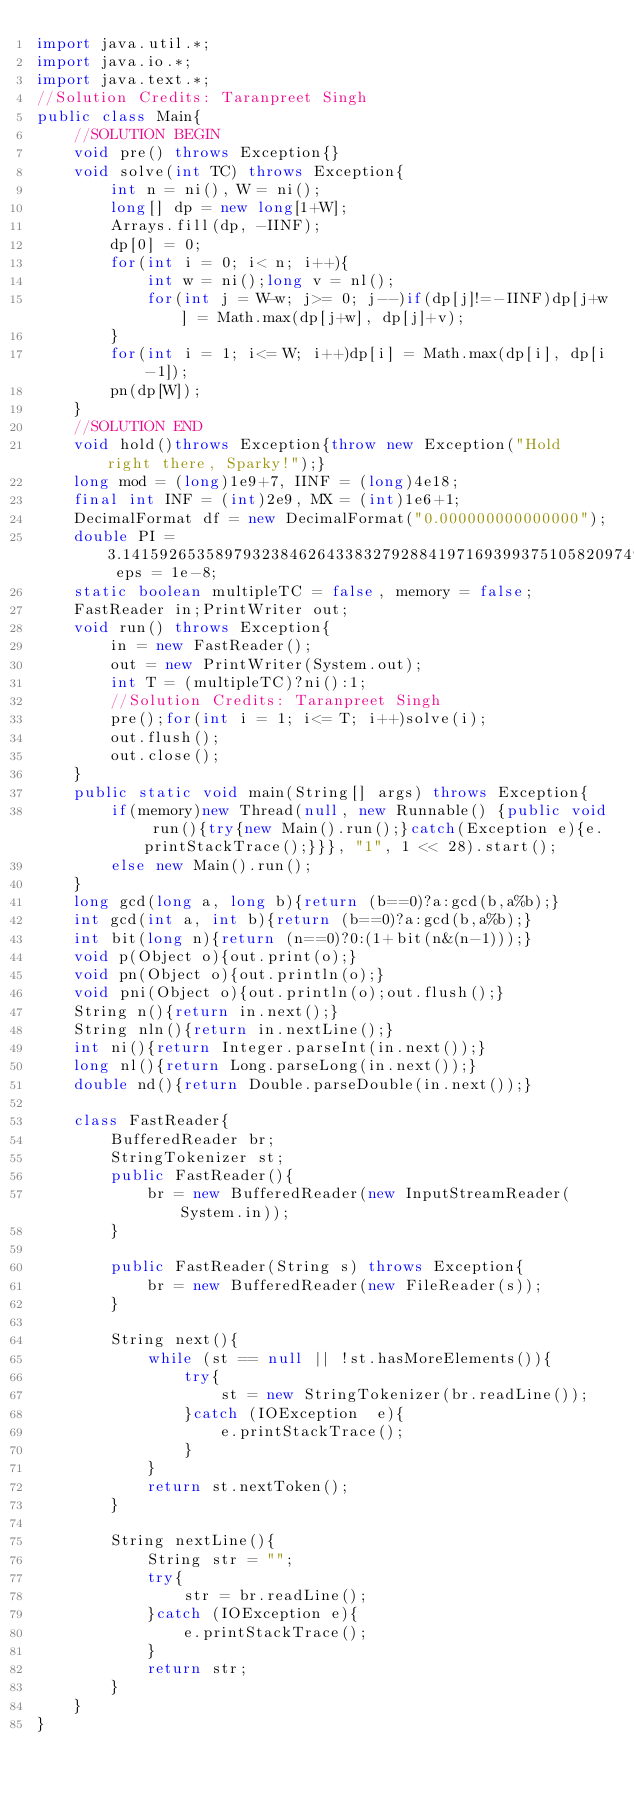<code> <loc_0><loc_0><loc_500><loc_500><_Java_>import java.util.*;
import java.io.*;
import java.text.*;
//Solution Credits: Taranpreet Singh
public class Main{
    //SOLUTION BEGIN
    void pre() throws Exception{}
    void solve(int TC) throws Exception{
        int n = ni(), W = ni();
        long[] dp = new long[1+W];
        Arrays.fill(dp, -IINF);
        dp[0] = 0;
        for(int i = 0; i< n; i++){
            int w = ni();long v = nl();
            for(int j = W-w; j>= 0; j--)if(dp[j]!=-IINF)dp[j+w] = Math.max(dp[j+w], dp[j]+v);
        }
        for(int i = 1; i<= W; i++)dp[i] = Math.max(dp[i], dp[i-1]);
        pn(dp[W]);
    }
    //SOLUTION END
    void hold()throws Exception{throw new Exception("Hold right there, Sparky!");}
    long mod = (long)1e9+7, IINF = (long)4e18;
    final int INF = (int)2e9, MX = (int)1e6+1;
    DecimalFormat df = new DecimalFormat("0.000000000000000");
    double PI = 3.1415926535897932384626433832792884197169399375105820974944, eps = 1e-8;
    static boolean multipleTC = false, memory = false;
    FastReader in;PrintWriter out;
    void run() throws Exception{
        in = new FastReader();
        out = new PrintWriter(System.out);
        int T = (multipleTC)?ni():1;
        //Solution Credits: Taranpreet Singh
        pre();for(int i = 1; i<= T; i++)solve(i);
        out.flush();
        out.close();
    }
    public static void main(String[] args) throws Exception{
        if(memory)new Thread(null, new Runnable() {public void run(){try{new Main().run();}catch(Exception e){e.printStackTrace();}}}, "1", 1 << 28).start();
        else new Main().run();
    }
    long gcd(long a, long b){return (b==0)?a:gcd(b,a%b);}
    int gcd(int a, int b){return (b==0)?a:gcd(b,a%b);}
    int bit(long n){return (n==0)?0:(1+bit(n&(n-1)));}
    void p(Object o){out.print(o);}
    void pn(Object o){out.println(o);}
    void pni(Object o){out.println(o);out.flush();}
    String n(){return in.next();}
    String nln(){return in.nextLine();}
    int ni(){return Integer.parseInt(in.next());}
    long nl(){return Long.parseLong(in.next());}
    double nd(){return Double.parseDouble(in.next());}

    class FastReader{
        BufferedReader br;
        StringTokenizer st;
        public FastReader(){
            br = new BufferedReader(new InputStreamReader(System.in));
        }

        public FastReader(String s) throws Exception{
            br = new BufferedReader(new FileReader(s));
        }

        String next(){
            while (st == null || !st.hasMoreElements()){
                try{
                    st = new StringTokenizer(br.readLine());
                }catch (IOException  e){
                    e.printStackTrace();
                }
            }
            return st.nextToken();
        }

        String nextLine(){
            String str = "";
            try{   
                str = br.readLine();
            }catch (IOException e){
                e.printStackTrace();
            }  
            return str;
        }
    }
}    </code> 